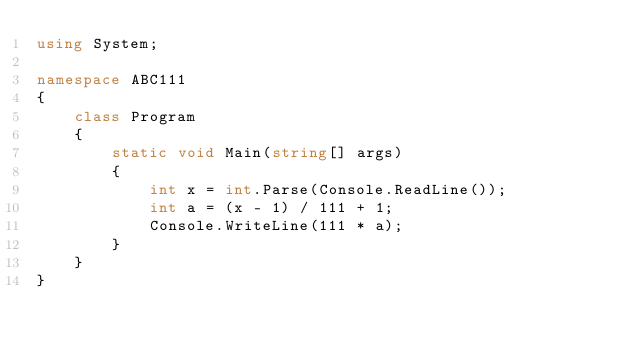<code> <loc_0><loc_0><loc_500><loc_500><_C#_>using System;

namespace ABC111
{
    class Program
    {
        static void Main(string[] args)
        {
            int x = int.Parse(Console.ReadLine());
            int a = (x - 1) / 111 + 1;
            Console.WriteLine(111 * a);
        }
    }
}
</code> 